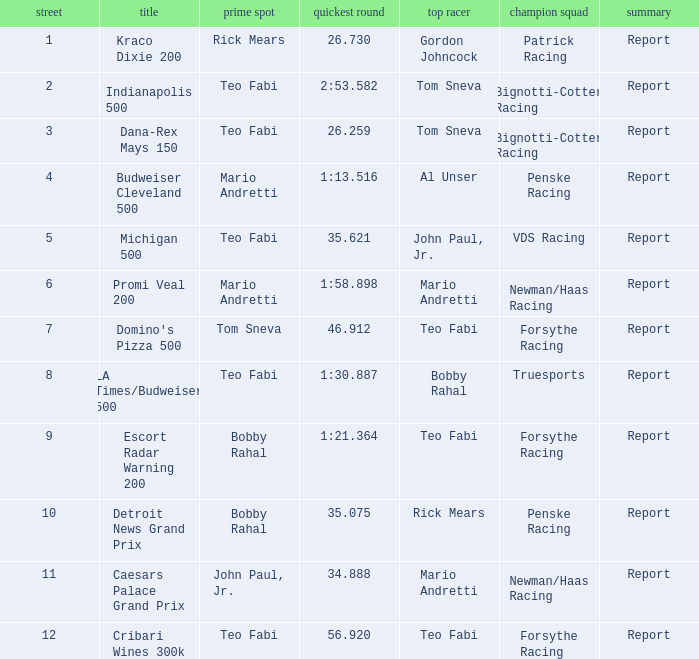Give me the full table as a dictionary. {'header': ['street', 'title', 'prime spot', 'quickest round', 'top racer', 'champion squad', 'summary'], 'rows': [['1', 'Kraco Dixie 200', 'Rick Mears', '26.730', 'Gordon Johncock', 'Patrick Racing', 'Report'], ['2', 'Indianapolis 500', 'Teo Fabi', '2:53.582', 'Tom Sneva', 'Bignotti-Cotter Racing', 'Report'], ['3', 'Dana-Rex Mays 150', 'Teo Fabi', '26.259', 'Tom Sneva', 'Bignotti-Cotter Racing', 'Report'], ['4', 'Budweiser Cleveland 500', 'Mario Andretti', '1:13.516', 'Al Unser', 'Penske Racing', 'Report'], ['5', 'Michigan 500', 'Teo Fabi', '35.621', 'John Paul, Jr.', 'VDS Racing', 'Report'], ['6', 'Promi Veal 200', 'Mario Andretti', '1:58.898', 'Mario Andretti', 'Newman/Haas Racing', 'Report'], ['7', "Domino's Pizza 500", 'Tom Sneva', '46.912', 'Teo Fabi', 'Forsythe Racing', 'Report'], ['8', 'LA Times/Budweiser 500', 'Teo Fabi', '1:30.887', 'Bobby Rahal', 'Truesports', 'Report'], ['9', 'Escort Radar Warning 200', 'Bobby Rahal', '1:21.364', 'Teo Fabi', 'Forsythe Racing', 'Report'], ['10', 'Detroit News Grand Prix', 'Bobby Rahal', '35.075', 'Rick Mears', 'Penske Racing', 'Report'], ['11', 'Caesars Palace Grand Prix', 'John Paul, Jr.', '34.888', 'Mario Andretti', 'Newman/Haas Racing', 'Report'], ['12', 'Cribari Wines 300k', 'Teo Fabi', '56.920', 'Teo Fabi', 'Forsythe Racing', 'Report']]} What is the highest Rd that Tom Sneva had the pole position in? 7.0. 